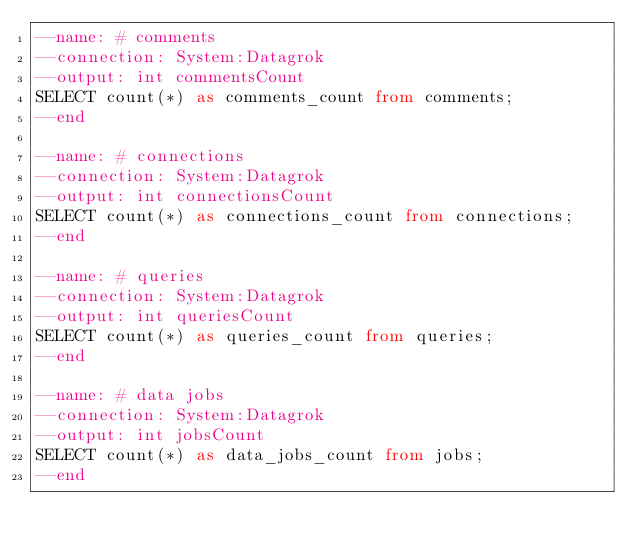Convert code to text. <code><loc_0><loc_0><loc_500><loc_500><_SQL_>--name: # comments
--connection: System:Datagrok
--output: int commentsCount
SELECT count(*) as comments_count from comments;
--end

--name: # connections
--connection: System:Datagrok
--output: int connectionsCount
SELECT count(*) as connections_count from connections;
--end

--name: # queries
--connection: System:Datagrok
--output: int queriesCount
SELECT count(*) as queries_count from queries;
--end

--name: # data jobs
--connection: System:Datagrok
--output: int jobsCount
SELECT count(*) as data_jobs_count from jobs;
--end
</code> 